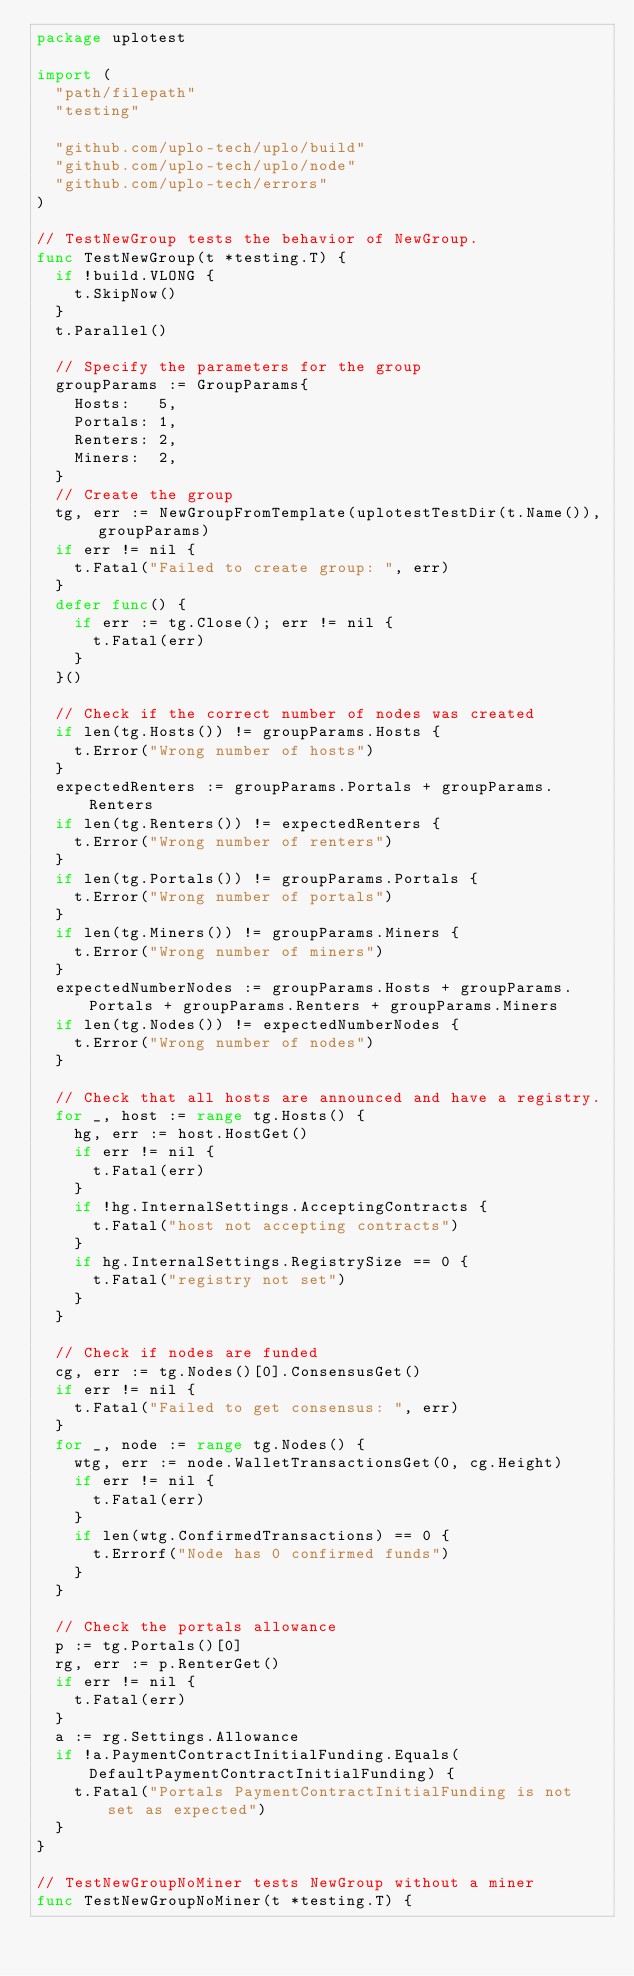<code> <loc_0><loc_0><loc_500><loc_500><_Go_>package uplotest

import (
	"path/filepath"
	"testing"

	"github.com/uplo-tech/uplo/build"
	"github.com/uplo-tech/uplo/node"
	"github.com/uplo-tech/errors"
)

// TestNewGroup tests the behavior of NewGroup.
func TestNewGroup(t *testing.T) {
	if !build.VLONG {
		t.SkipNow()
	}
	t.Parallel()

	// Specify the parameters for the group
	groupParams := GroupParams{
		Hosts:   5,
		Portals: 1,
		Renters: 2,
		Miners:  2,
	}
	// Create the group
	tg, err := NewGroupFromTemplate(uplotestTestDir(t.Name()), groupParams)
	if err != nil {
		t.Fatal("Failed to create group: ", err)
	}
	defer func() {
		if err := tg.Close(); err != nil {
			t.Fatal(err)
		}
	}()

	// Check if the correct number of nodes was created
	if len(tg.Hosts()) != groupParams.Hosts {
		t.Error("Wrong number of hosts")
	}
	expectedRenters := groupParams.Portals + groupParams.Renters
	if len(tg.Renters()) != expectedRenters {
		t.Error("Wrong number of renters")
	}
	if len(tg.Portals()) != groupParams.Portals {
		t.Error("Wrong number of portals")
	}
	if len(tg.Miners()) != groupParams.Miners {
		t.Error("Wrong number of miners")
	}
	expectedNumberNodes := groupParams.Hosts + groupParams.Portals + groupParams.Renters + groupParams.Miners
	if len(tg.Nodes()) != expectedNumberNodes {
		t.Error("Wrong number of nodes")
	}

	// Check that all hosts are announced and have a registry.
	for _, host := range tg.Hosts() {
		hg, err := host.HostGet()
		if err != nil {
			t.Fatal(err)
		}
		if !hg.InternalSettings.AcceptingContracts {
			t.Fatal("host not accepting contracts")
		}
		if hg.InternalSettings.RegistrySize == 0 {
			t.Fatal("registry not set")
		}
	}

	// Check if nodes are funded
	cg, err := tg.Nodes()[0].ConsensusGet()
	if err != nil {
		t.Fatal("Failed to get consensus: ", err)
	}
	for _, node := range tg.Nodes() {
		wtg, err := node.WalletTransactionsGet(0, cg.Height)
		if err != nil {
			t.Fatal(err)
		}
		if len(wtg.ConfirmedTransactions) == 0 {
			t.Errorf("Node has 0 confirmed funds")
		}
	}

	// Check the portals allowance
	p := tg.Portals()[0]
	rg, err := p.RenterGet()
	if err != nil {
		t.Fatal(err)
	}
	a := rg.Settings.Allowance
	if !a.PaymentContractInitialFunding.Equals(DefaultPaymentContractInitialFunding) {
		t.Fatal("Portals PaymentContractInitialFunding is not set as expected")
	}
}

// TestNewGroupNoMiner tests NewGroup without a miner
func TestNewGroupNoMiner(t *testing.T) {</code> 